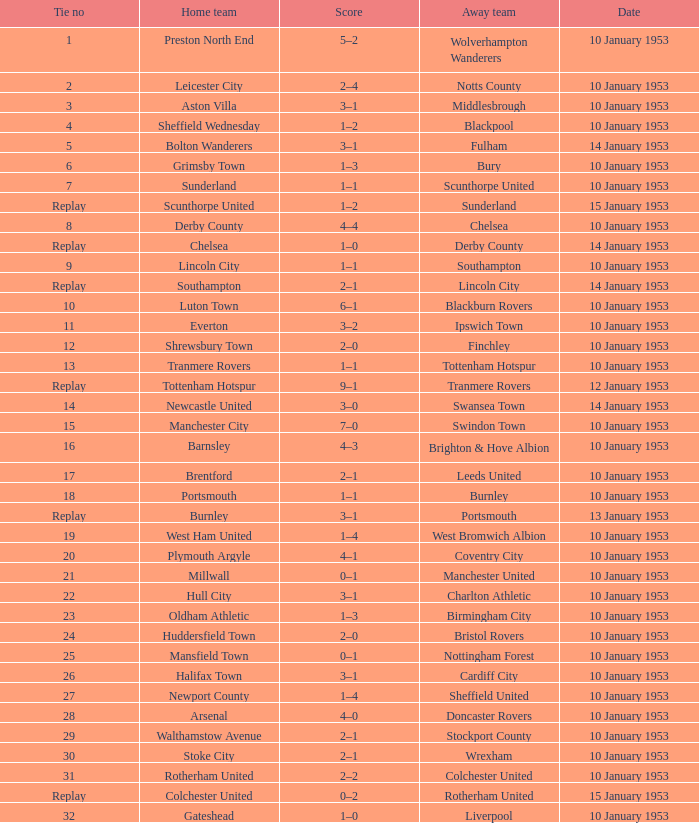What score has charlton athletic as the away team? 3–1. 